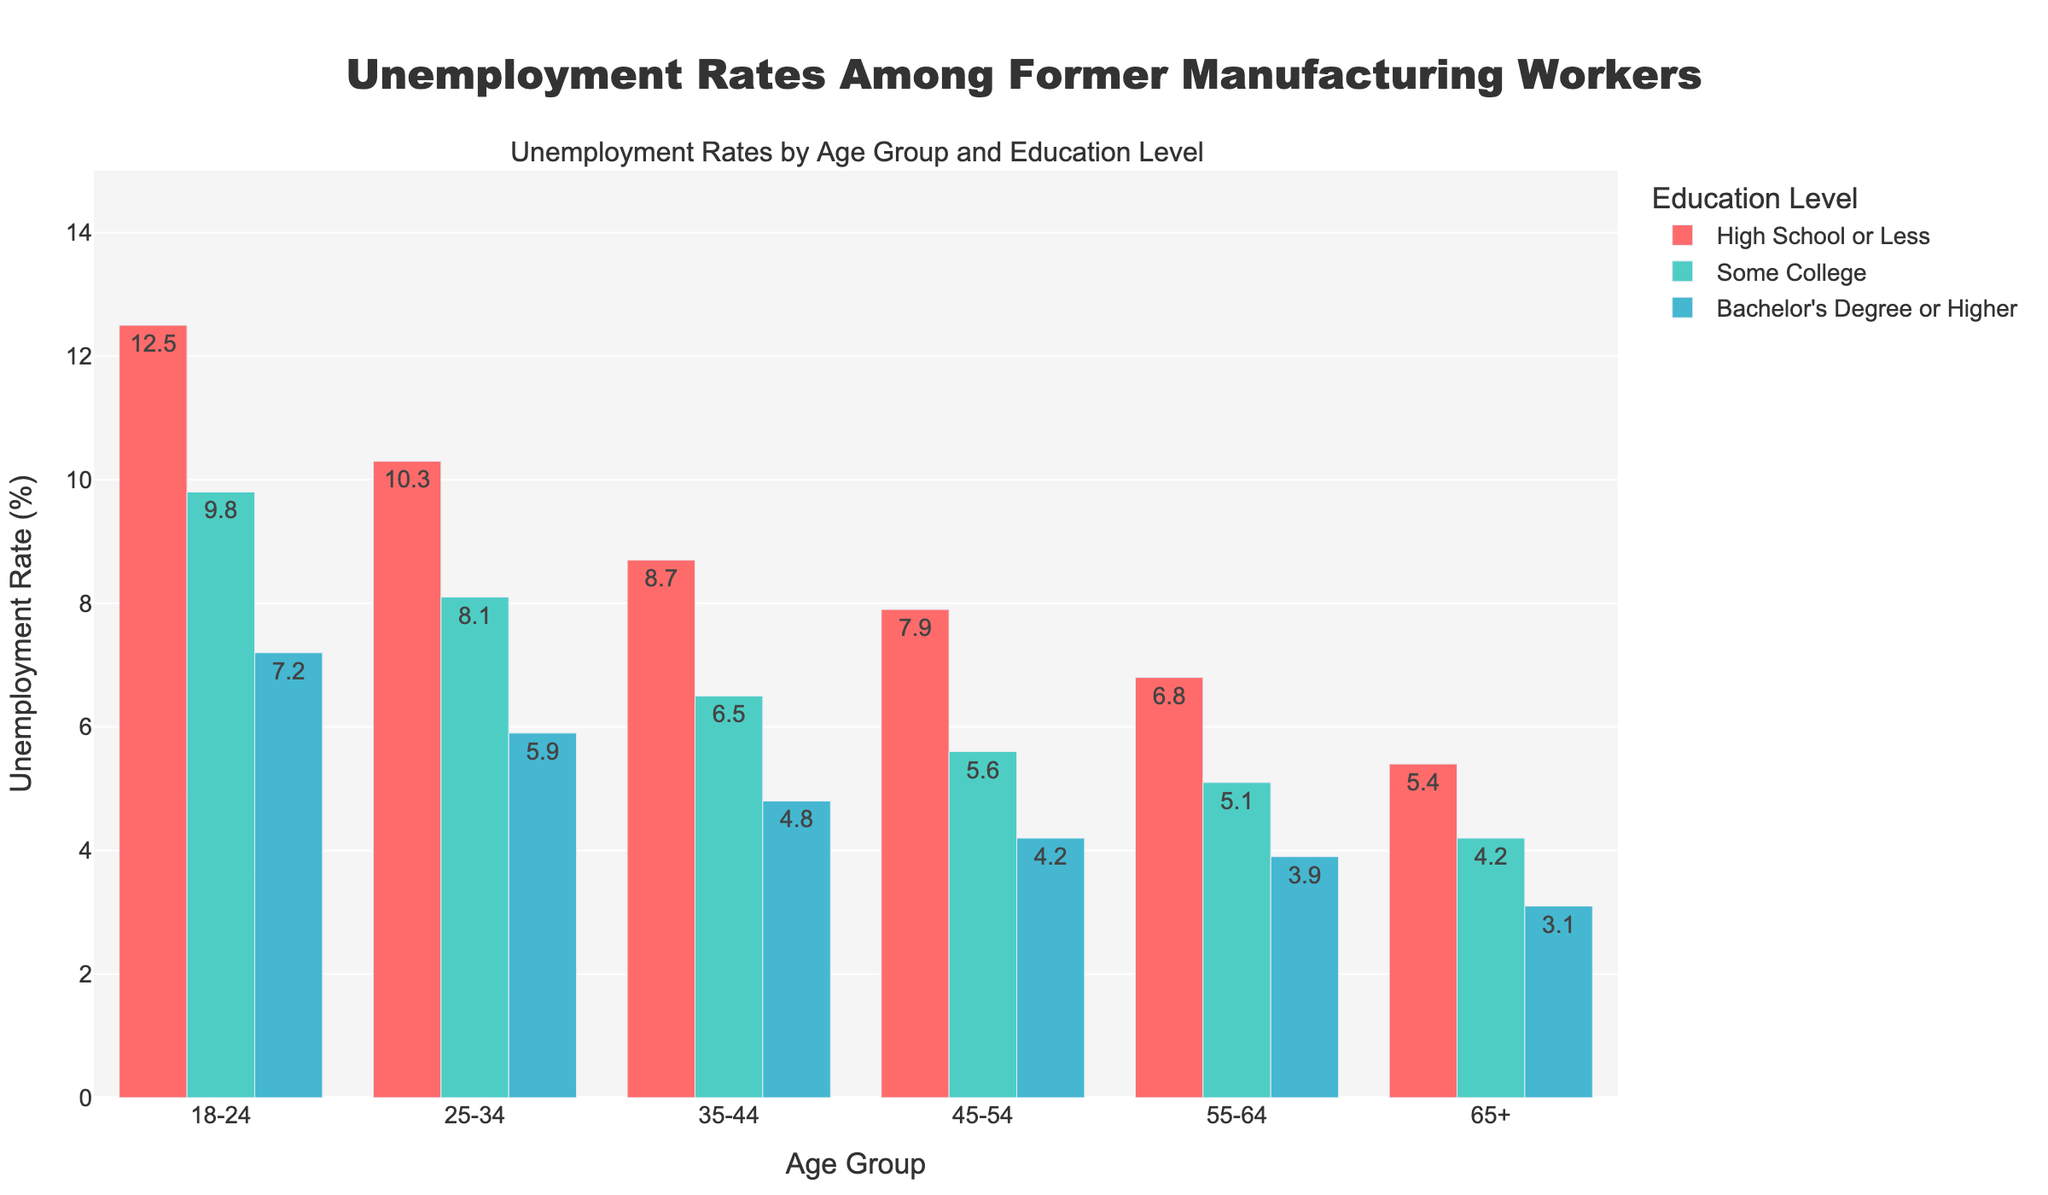Which age group with a high school or less education level has the highest unemployment rate? Look at the bars for the "High School or Less" education level across all age groups and find the tallest bar. The highest unemployment rate for this education level is in the 18-24 age group with a rate of 12.5%.
Answer: 18-24 Which education level has the lowest unemployment rate for the 45-54 age group? Examine the bars for the 45-54 age group and compare the heights of the bars representing different education levels. The "Bachelor's Degree or Higher" education level has the lowest unemployment rate for this age group at 4.2%.
Answer: Bachelor's Degree or Higher What is the difference in unemployment rates between the 18-24 age group with a high school or less education and the 25-34 age group with a bachelor's degree or higher? Find the unemployment rate for the 18-24 age group with "High School or Less" (12.5%) and for the 25-34 age group with "Bachelor's Degree or Higher" (5.9%). Subtract the smaller rate from the larger one: 12.5% - 5.9% = 6.6%.
Answer: 6.6% Which education level shows the most consistent decrease in unemployment rates as age increases? Compare the trends for all education levels across different age groups. The "Bachelor's Degree or Higher" education level shows the most consistent decrease in unemployment rates starting from 7.2% in the 18-24 age group down to 3.1% in the 65+ age group.
Answer: Bachelor's Degree or Higher What is the average unemployment rate for people aged 55-64 across all education levels? Find the unemployment rates for each education level within the 55-64 age group: High School or Less (6.8%), Some College (5.1%), Bachelor's Degree or Higher (3.9%). Calculate the average: (6.8% + 5.1% + 3.9%) / 3 ≈ 5.27%.
Answer: 5.27% Compare the unemployment rate for the 25-34 age group with some college education to the 35-44 age group with the same education level. Which is lower, and by how much? Note the unemployment rates: 8.1% for 25-34 with some college and 6.5% for 35-44 with some college. Subtract the smaller rate from the larger rate: 8.1% - 6.5% = 1.6%. The 35-44 group has a lower unemployment rate.
Answer: 35-44 by 1.6% Which age group has the lowest unemployment rate for people with high school or less education? Scan the bars for "High School or Less" education and find the age group with the lowest height bar. The 65+ age group has the lowest rate at 5.4%.
Answer: 65+ What is the range of unemployment rates for people with some college education across all age groups? Find the minimum and maximum unemployment rates for "Some College" education. The minimum is 4.2% (65+ age group) and the maximum is 9.8% (18-24 age group). Calculate the range: 9.8% - 4.2% = 5.6%.
Answer: 5.6% Between which two adjacent age groups is the greatest decrease in unemployment rate observed for people with a high school or less education? Compare the unemployment rate decreases between adjacent age groups for "High School or Less" education. The largest decrease is from 18-24 (12.5%) to 25-34 (10.3%), which is a decrease of 12.5% - 10.3% = 2.2%.
Answer: 18-24 to 25-34 